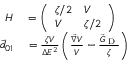<formula> <loc_0><loc_0><loc_500><loc_500>\begin{array} { r l } { H } & = \left ( \begin{array} { l l } { \zeta / 2 } & { V } \\ { V } & { \zeta / 2 } \end{array} \right ) } \\ { \vec { d } _ { 0 1 } } & = \frac { \zeta V } { \Delta E ^ { 2 } } \left ( \frac { \vec { \nabla } V } { V } - \frac { \vec { G } _ { D } } { \zeta } \right ) } \end{array}</formula> 